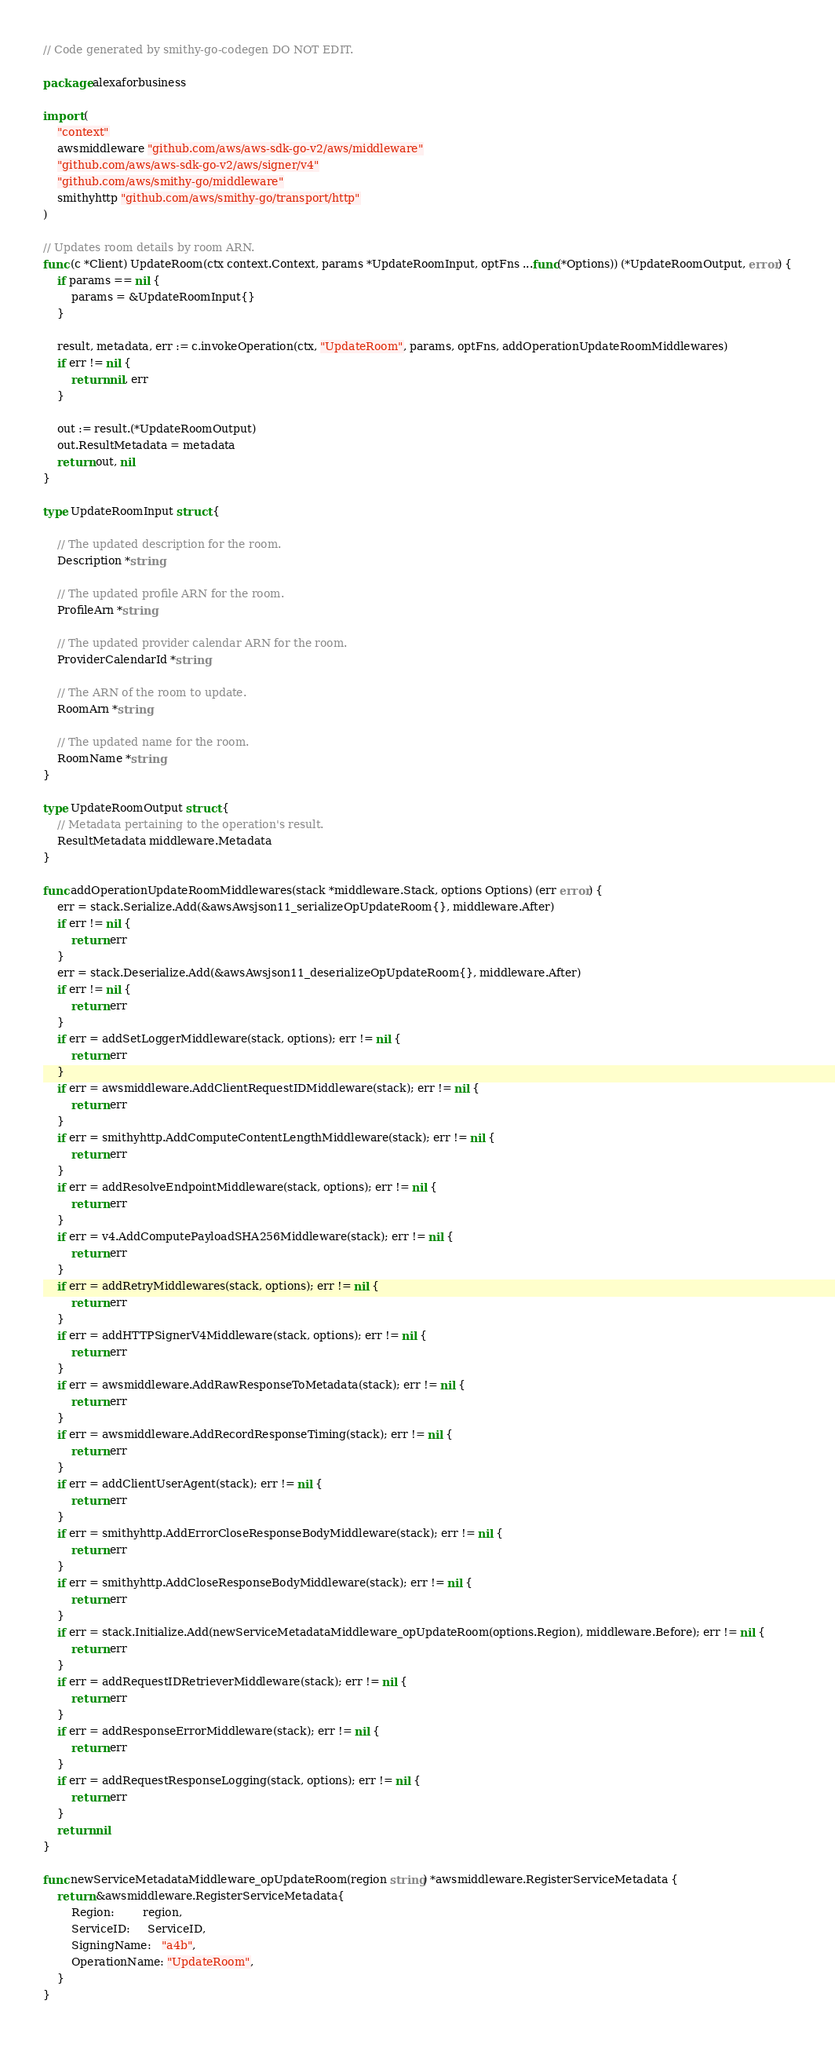<code> <loc_0><loc_0><loc_500><loc_500><_Go_>// Code generated by smithy-go-codegen DO NOT EDIT.

package alexaforbusiness

import (
	"context"
	awsmiddleware "github.com/aws/aws-sdk-go-v2/aws/middleware"
	"github.com/aws/aws-sdk-go-v2/aws/signer/v4"
	"github.com/aws/smithy-go/middleware"
	smithyhttp "github.com/aws/smithy-go/transport/http"
)

// Updates room details by room ARN.
func (c *Client) UpdateRoom(ctx context.Context, params *UpdateRoomInput, optFns ...func(*Options)) (*UpdateRoomOutput, error) {
	if params == nil {
		params = &UpdateRoomInput{}
	}

	result, metadata, err := c.invokeOperation(ctx, "UpdateRoom", params, optFns, addOperationUpdateRoomMiddlewares)
	if err != nil {
		return nil, err
	}

	out := result.(*UpdateRoomOutput)
	out.ResultMetadata = metadata
	return out, nil
}

type UpdateRoomInput struct {

	// The updated description for the room.
	Description *string

	// The updated profile ARN for the room.
	ProfileArn *string

	// The updated provider calendar ARN for the room.
	ProviderCalendarId *string

	// The ARN of the room to update.
	RoomArn *string

	// The updated name for the room.
	RoomName *string
}

type UpdateRoomOutput struct {
	// Metadata pertaining to the operation's result.
	ResultMetadata middleware.Metadata
}

func addOperationUpdateRoomMiddlewares(stack *middleware.Stack, options Options) (err error) {
	err = stack.Serialize.Add(&awsAwsjson11_serializeOpUpdateRoom{}, middleware.After)
	if err != nil {
		return err
	}
	err = stack.Deserialize.Add(&awsAwsjson11_deserializeOpUpdateRoom{}, middleware.After)
	if err != nil {
		return err
	}
	if err = addSetLoggerMiddleware(stack, options); err != nil {
		return err
	}
	if err = awsmiddleware.AddClientRequestIDMiddleware(stack); err != nil {
		return err
	}
	if err = smithyhttp.AddComputeContentLengthMiddleware(stack); err != nil {
		return err
	}
	if err = addResolveEndpointMiddleware(stack, options); err != nil {
		return err
	}
	if err = v4.AddComputePayloadSHA256Middleware(stack); err != nil {
		return err
	}
	if err = addRetryMiddlewares(stack, options); err != nil {
		return err
	}
	if err = addHTTPSignerV4Middleware(stack, options); err != nil {
		return err
	}
	if err = awsmiddleware.AddRawResponseToMetadata(stack); err != nil {
		return err
	}
	if err = awsmiddleware.AddRecordResponseTiming(stack); err != nil {
		return err
	}
	if err = addClientUserAgent(stack); err != nil {
		return err
	}
	if err = smithyhttp.AddErrorCloseResponseBodyMiddleware(stack); err != nil {
		return err
	}
	if err = smithyhttp.AddCloseResponseBodyMiddleware(stack); err != nil {
		return err
	}
	if err = stack.Initialize.Add(newServiceMetadataMiddleware_opUpdateRoom(options.Region), middleware.Before); err != nil {
		return err
	}
	if err = addRequestIDRetrieverMiddleware(stack); err != nil {
		return err
	}
	if err = addResponseErrorMiddleware(stack); err != nil {
		return err
	}
	if err = addRequestResponseLogging(stack, options); err != nil {
		return err
	}
	return nil
}

func newServiceMetadataMiddleware_opUpdateRoom(region string) *awsmiddleware.RegisterServiceMetadata {
	return &awsmiddleware.RegisterServiceMetadata{
		Region:        region,
		ServiceID:     ServiceID,
		SigningName:   "a4b",
		OperationName: "UpdateRoom",
	}
}
</code> 